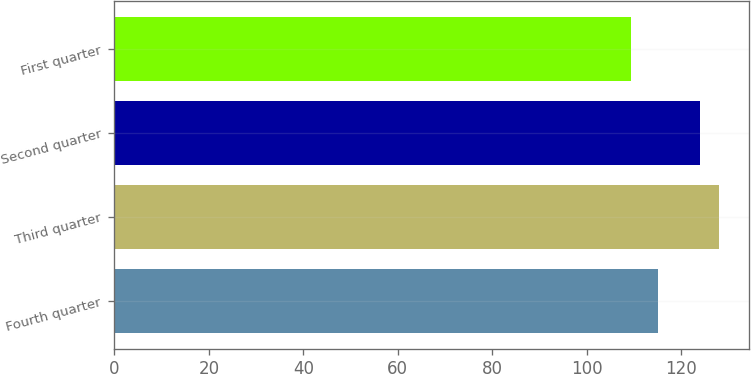Convert chart. <chart><loc_0><loc_0><loc_500><loc_500><bar_chart><fcel>Fourth quarter<fcel>Third quarter<fcel>Second quarter<fcel>First quarter<nl><fcel>115.15<fcel>128.08<fcel>124.11<fcel>109.4<nl></chart> 